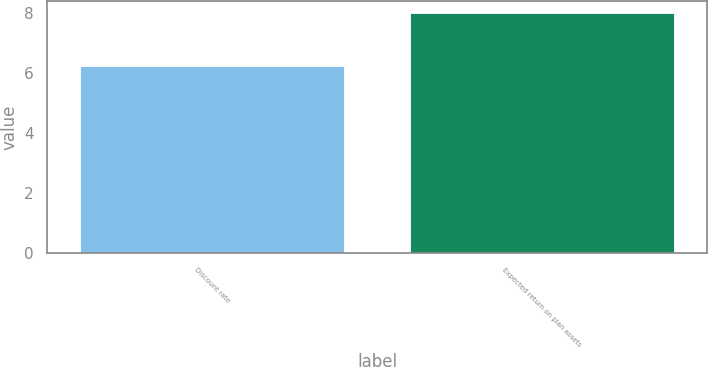<chart> <loc_0><loc_0><loc_500><loc_500><bar_chart><fcel>Discount rate<fcel>Expected return on plan assets<nl><fcel>6.25<fcel>8<nl></chart> 